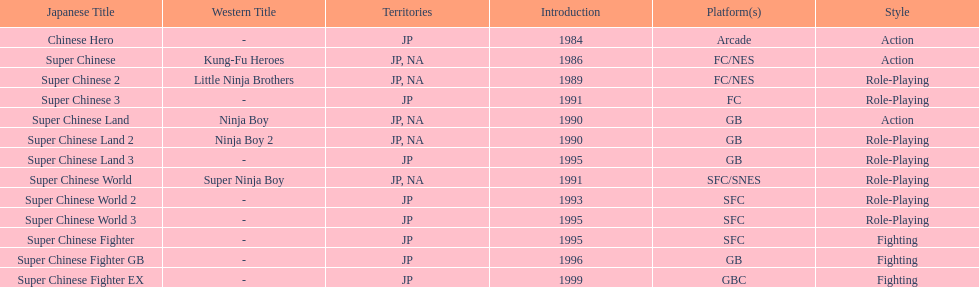The first year a game was released in north america 1986. 